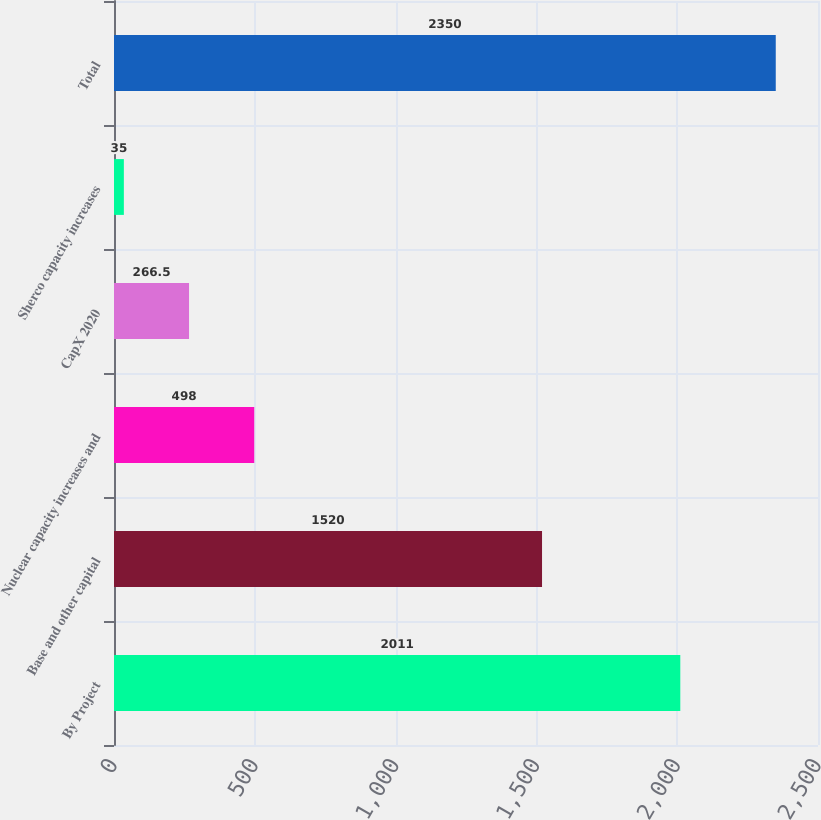Convert chart. <chart><loc_0><loc_0><loc_500><loc_500><bar_chart><fcel>By Project<fcel>Base and other capital<fcel>Nuclear capacity increases and<fcel>CapX 2020<fcel>Sherco capacity increases<fcel>Total<nl><fcel>2011<fcel>1520<fcel>498<fcel>266.5<fcel>35<fcel>2350<nl></chart> 